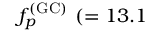<formula> <loc_0><loc_0><loc_500><loc_500>f _ { p } ^ { ( G C ) } ( = 1 3 . 1</formula> 